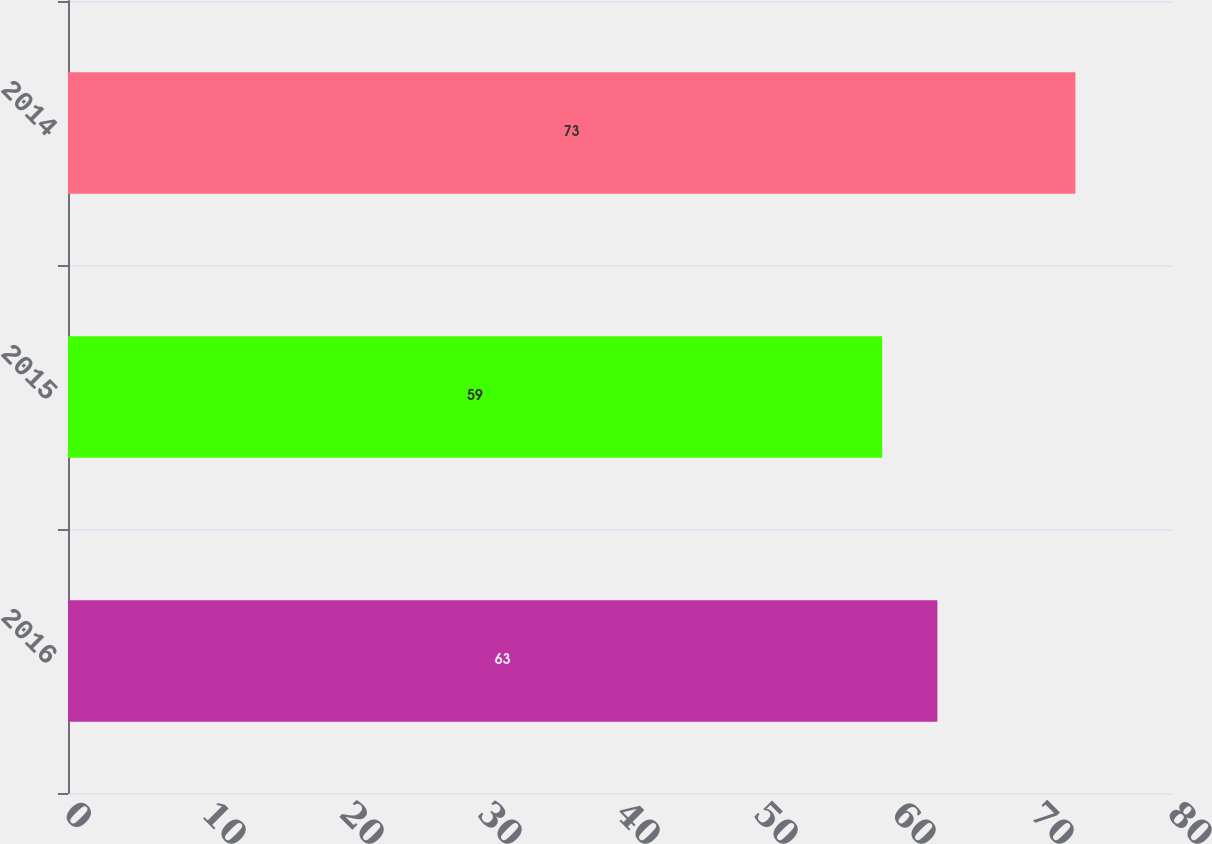<chart> <loc_0><loc_0><loc_500><loc_500><bar_chart><fcel>2016<fcel>2015<fcel>2014<nl><fcel>63<fcel>59<fcel>73<nl></chart> 